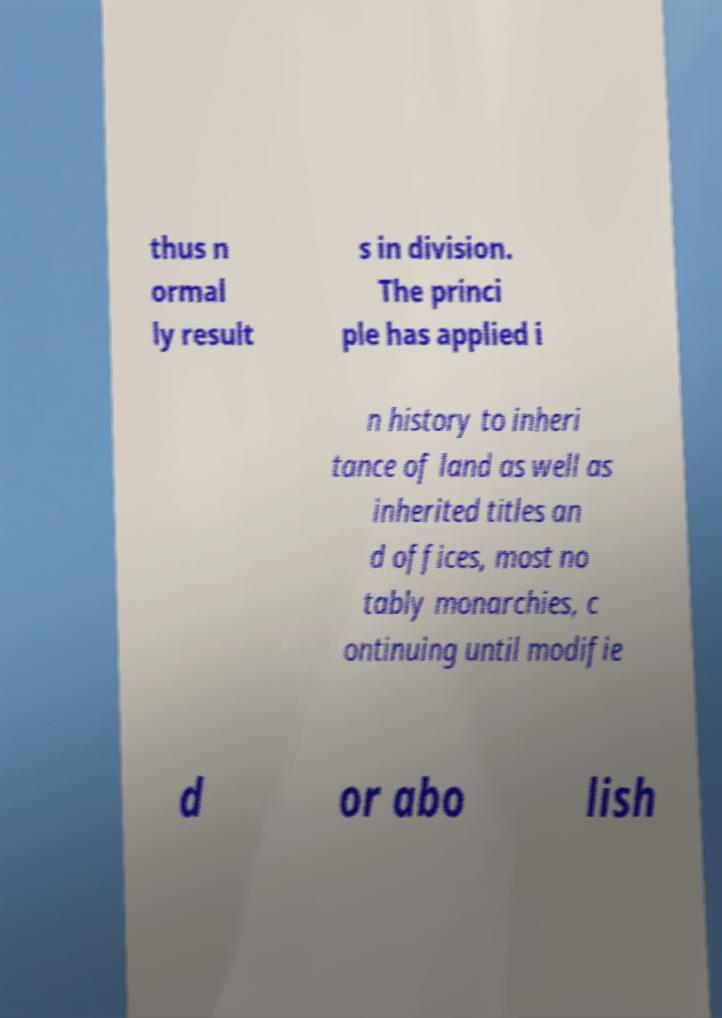I need the written content from this picture converted into text. Can you do that? thus n ormal ly result s in division. The princi ple has applied i n history to inheri tance of land as well as inherited titles an d offices, most no tably monarchies, c ontinuing until modifie d or abo lish 